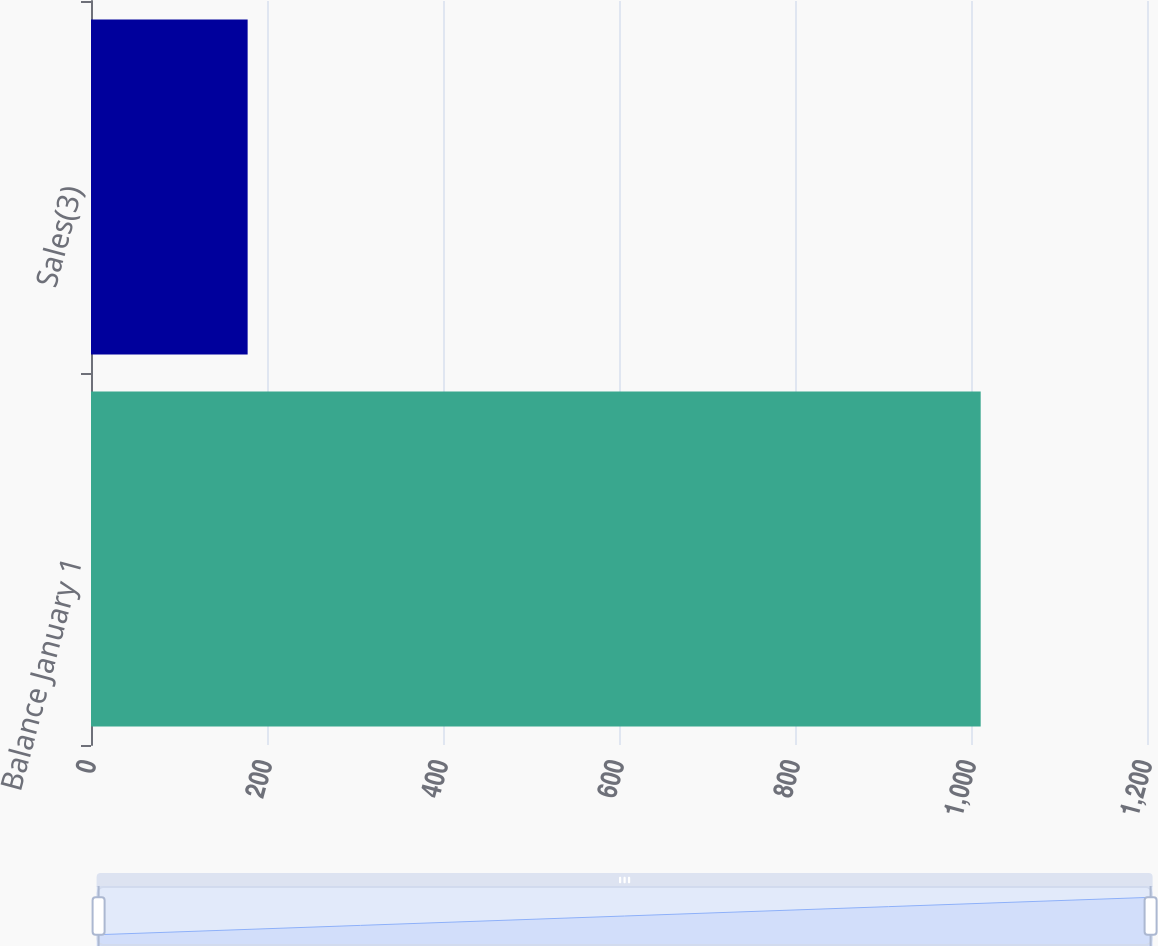Convert chart to OTSL. <chart><loc_0><loc_0><loc_500><loc_500><bar_chart><fcel>Balance January 1<fcel>Sales(3)<nl><fcel>1011<fcel>178<nl></chart> 